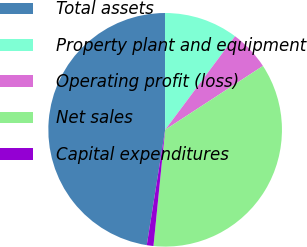Convert chart to OTSL. <chart><loc_0><loc_0><loc_500><loc_500><pie_chart><fcel>Total assets<fcel>Property plant and equipment<fcel>Operating profit (loss)<fcel>Net sales<fcel>Capital expenditures<nl><fcel>47.46%<fcel>10.23%<fcel>5.58%<fcel>35.8%<fcel>0.92%<nl></chart> 